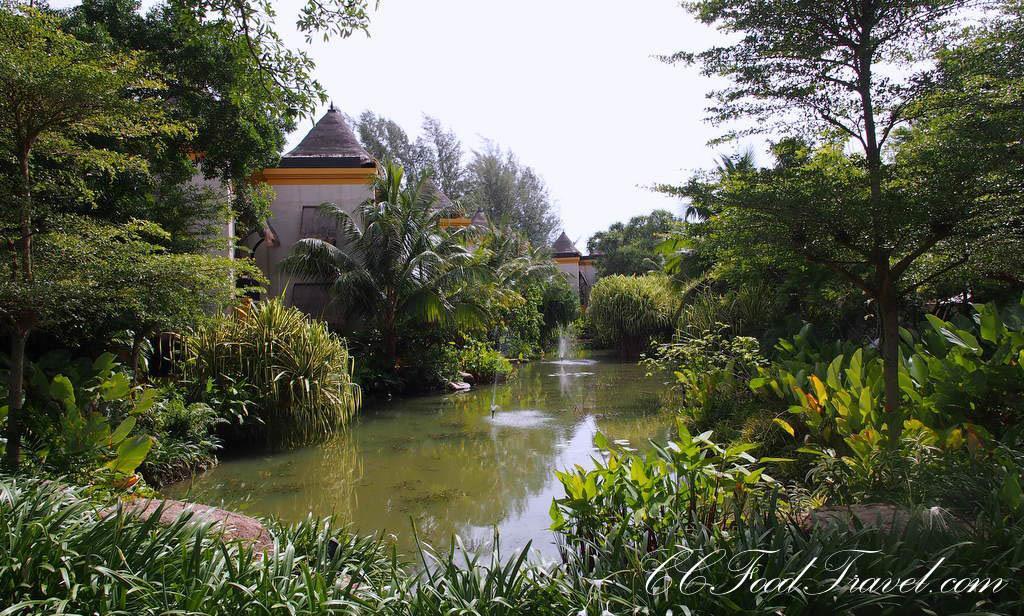Can you describe this image briefly? In this image I can see a house there are some trees, plants visible in the middle , there is the water visible , at the bottom there is the text, at the top there is the sky. 